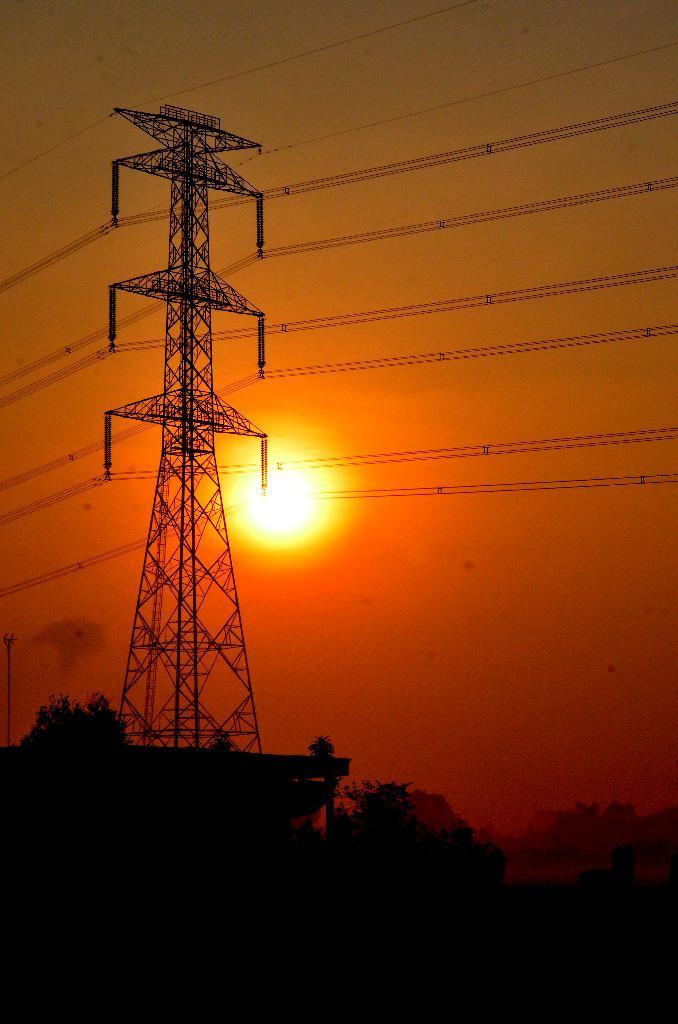Please provide a concise description of this image. In this image I can see few trees, an electric tower and number of wires in the front. In the background I can see the sun and the sky. 